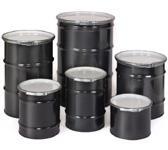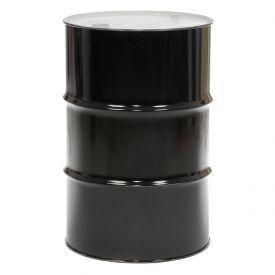The first image is the image on the left, the second image is the image on the right. Examine the images to the left and right. Is the description "The right image contains exactly one black barrel." accurate? Answer yes or no. Yes. The first image is the image on the left, the second image is the image on the right. Examine the images to the left and right. Is the description "The image on the right has a single canister while the image on the left has six." accurate? Answer yes or no. Yes. 